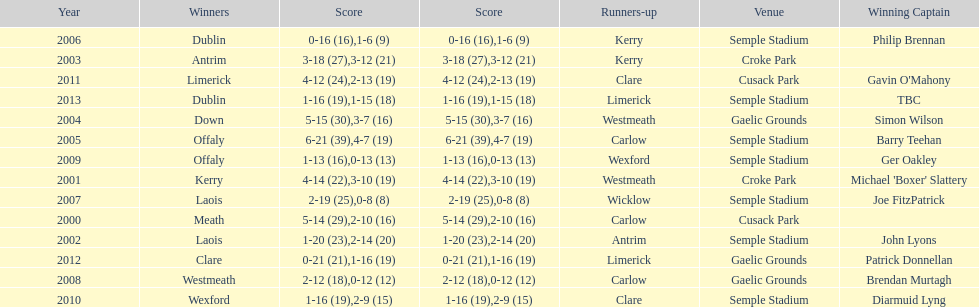Who was the winning captain the last time the competition was held at the gaelic grounds venue? Patrick Donnellan. 